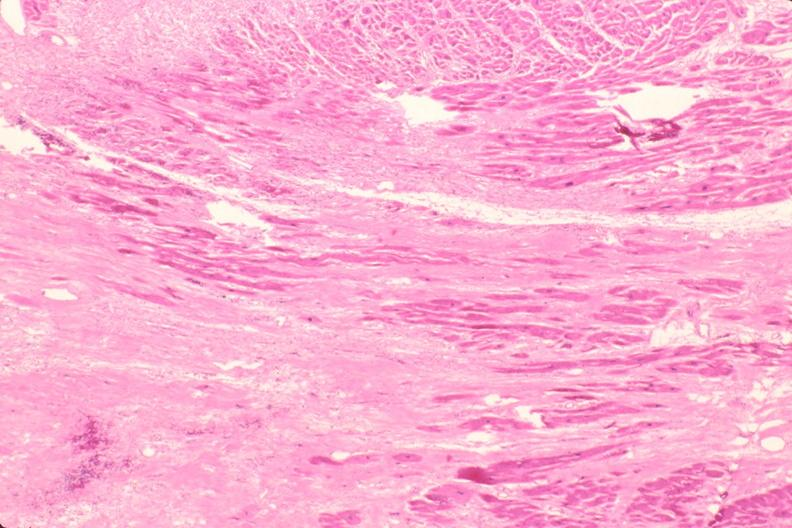s cardiovascular present?
Answer the question using a single word or phrase. Yes 